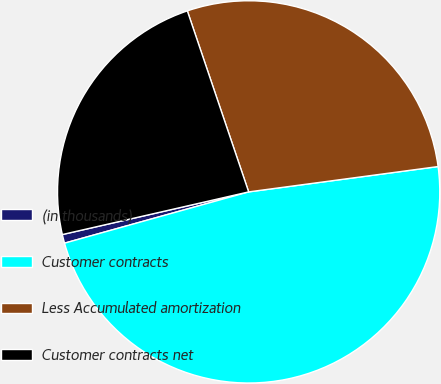Convert chart to OTSL. <chart><loc_0><loc_0><loc_500><loc_500><pie_chart><fcel>(in thousands)<fcel>Customer contracts<fcel>Less Accumulated amortization<fcel>Customer contracts net<nl><fcel>0.74%<fcel>47.79%<fcel>28.08%<fcel>23.38%<nl></chart> 